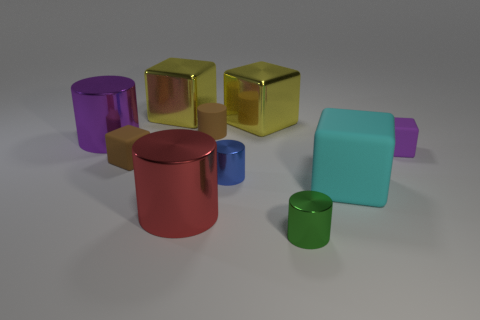There is a matte cube in front of the brown cube; is its size the same as the red metallic cylinder?
Offer a very short reply. Yes. What number of purple matte objects have the same shape as the big purple metal object?
Make the answer very short. 0. The purple cylinder that is the same material as the big red cylinder is what size?
Your answer should be very brief. Large. Are there the same number of big cyan rubber objects behind the tiny brown cylinder and green metallic objects?
Ensure brevity in your answer.  No. Do the large matte block and the small matte cylinder have the same color?
Your response must be concise. No. There is a big metallic thing that is in front of the big rubber block; is it the same shape as the brown object that is in front of the large purple cylinder?
Offer a terse response. No. There is a brown thing that is the same shape as the cyan rubber thing; what is its material?
Keep it short and to the point. Rubber. There is a matte block that is behind the cyan rubber cube and on the right side of the red cylinder; what color is it?
Offer a terse response. Purple. Are there any objects that are to the right of the small matte cube that is behind the tiny matte cube on the left side of the small green cylinder?
Make the answer very short. No. How many objects are red rubber things or tiny brown cubes?
Provide a short and direct response. 1. 